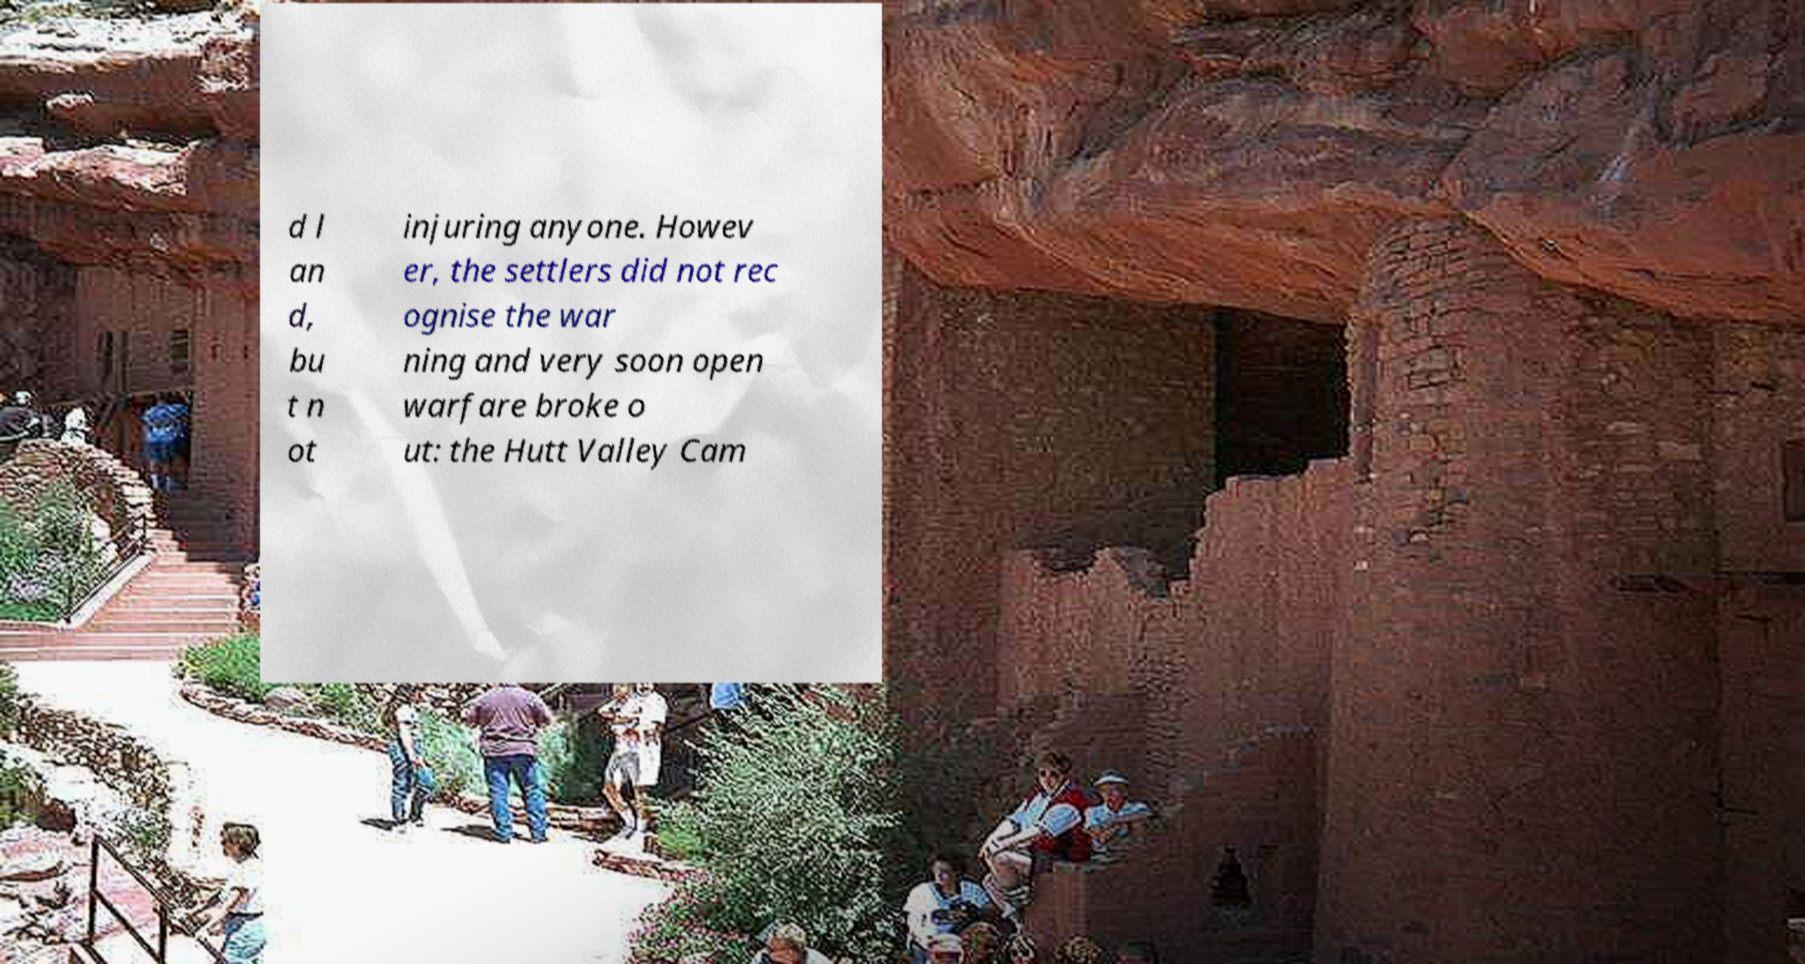There's text embedded in this image that I need extracted. Can you transcribe it verbatim? d l an d, bu t n ot injuring anyone. Howev er, the settlers did not rec ognise the war ning and very soon open warfare broke o ut: the Hutt Valley Cam 